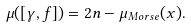Convert formula to latex. <formula><loc_0><loc_0><loc_500><loc_500>\mu ( [ \gamma , f ] ) = 2 n - \mu _ { M o r s e } ( x ) .</formula> 